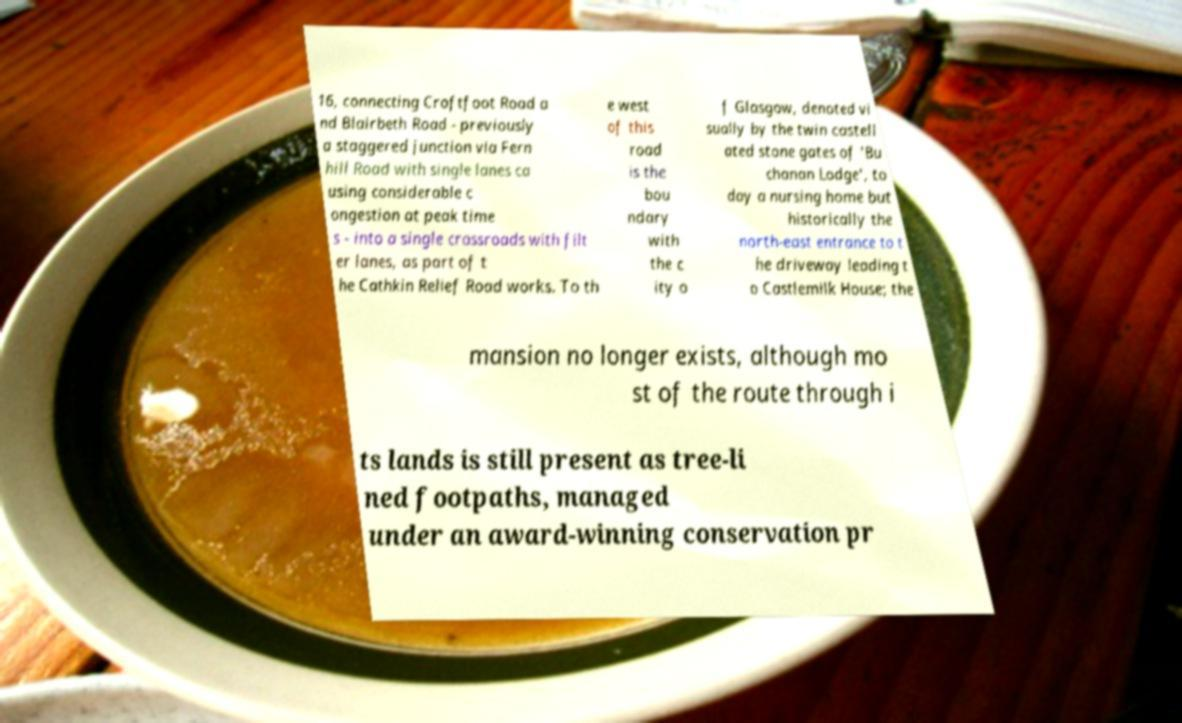Please identify and transcribe the text found in this image. 16, connecting Croftfoot Road a nd Blairbeth Road - previously a staggered junction via Fern hill Road with single lanes ca using considerable c ongestion at peak time s - into a single crossroads with filt er lanes, as part of t he Cathkin Relief Road works. To th e west of this road is the bou ndary with the c ity o f Glasgow, denoted vi sually by the twin castell ated stone gates of 'Bu chanan Lodge', to day a nursing home but historically the north-east entrance to t he driveway leading t o Castlemilk House; the mansion no longer exists, although mo st of the route through i ts lands is still present as tree-li ned footpaths, managed under an award-winning conservation pr 